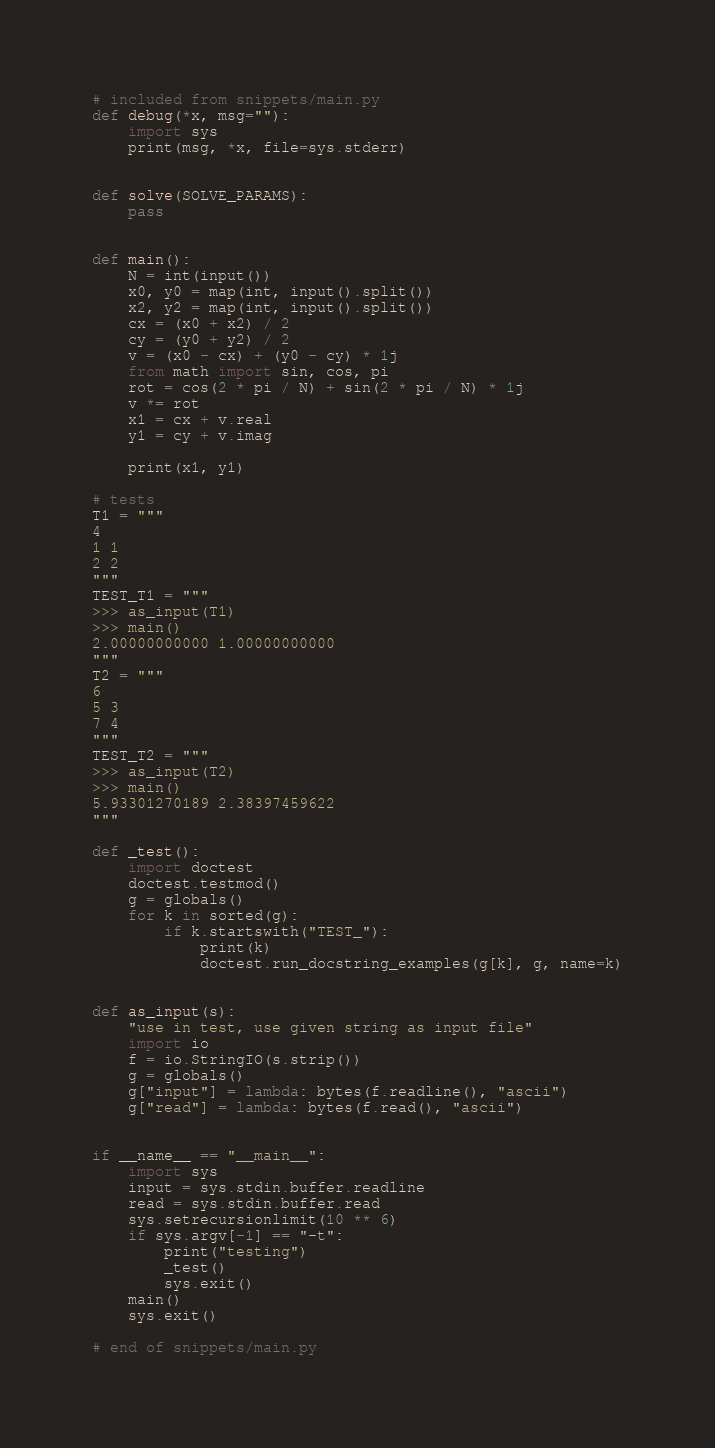Convert code to text. <code><loc_0><loc_0><loc_500><loc_500><_Python_># included from snippets/main.py
def debug(*x, msg=""):
    import sys
    print(msg, *x, file=sys.stderr)


def solve(SOLVE_PARAMS):
    pass


def main():
    N = int(input())
    x0, y0 = map(int, input().split())
    x2, y2 = map(int, input().split())
    cx = (x0 + x2) / 2
    cy = (y0 + y2) / 2
    v = (x0 - cx) + (y0 - cy) * 1j
    from math import sin, cos, pi
    rot = cos(2 * pi / N) + sin(2 * pi / N) * 1j
    v *= rot
    x1 = cx + v.real
    y1 = cy + v.imag

    print(x1, y1)

# tests
T1 = """
4
1 1
2 2
"""
TEST_T1 = """
>>> as_input(T1)
>>> main()
2.00000000000 1.00000000000
"""
T2 = """
6
5 3
7 4
"""
TEST_T2 = """
>>> as_input(T2)
>>> main()
5.93301270189 2.38397459622
"""

def _test():
    import doctest
    doctest.testmod()
    g = globals()
    for k in sorted(g):
        if k.startswith("TEST_"):
            print(k)
            doctest.run_docstring_examples(g[k], g, name=k)


def as_input(s):
    "use in test, use given string as input file"
    import io
    f = io.StringIO(s.strip())
    g = globals()
    g["input"] = lambda: bytes(f.readline(), "ascii")
    g["read"] = lambda: bytes(f.read(), "ascii")


if __name__ == "__main__":
    import sys
    input = sys.stdin.buffer.readline
    read = sys.stdin.buffer.read
    sys.setrecursionlimit(10 ** 6)
    if sys.argv[-1] == "-t":
        print("testing")
        _test()
        sys.exit()
    main()
    sys.exit()

# end of snippets/main.py</code> 